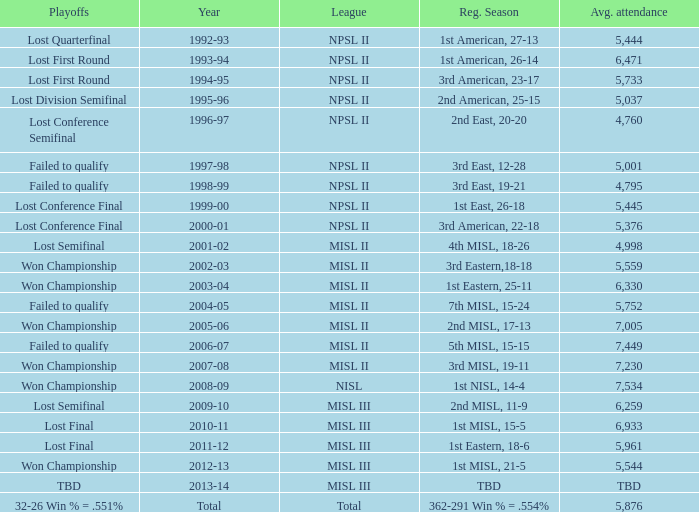Would you mind parsing the complete table? {'header': ['Playoffs', 'Year', 'League', 'Reg. Season', 'Avg. attendance'], 'rows': [['Lost Quarterfinal', '1992-93', 'NPSL II', '1st American, 27-13', '5,444'], ['Lost First Round', '1993-94', 'NPSL II', '1st American, 26-14', '6,471'], ['Lost First Round', '1994-95', 'NPSL II', '3rd American, 23-17', '5,733'], ['Lost Division Semifinal', '1995-96', 'NPSL II', '2nd American, 25-15', '5,037'], ['Lost Conference Semifinal', '1996-97', 'NPSL II', '2nd East, 20-20', '4,760'], ['Failed to qualify', '1997-98', 'NPSL II', '3rd East, 12-28', '5,001'], ['Failed to qualify', '1998-99', 'NPSL II', '3rd East, 19-21', '4,795'], ['Lost Conference Final', '1999-00', 'NPSL II', '1st East, 26-18', '5,445'], ['Lost Conference Final', '2000-01', 'NPSL II', '3rd American, 22-18', '5,376'], ['Lost Semifinal', '2001-02', 'MISL II', '4th MISL, 18-26', '4,998'], ['Won Championship', '2002-03', 'MISL II', '3rd Eastern,18-18', '5,559'], ['Won Championship', '2003-04', 'MISL II', '1st Eastern, 25-11', '6,330'], ['Failed to qualify', '2004-05', 'MISL II', '7th MISL, 15-24', '5,752'], ['Won Championship', '2005-06', 'MISL II', '2nd MISL, 17-13', '7,005'], ['Failed to qualify', '2006-07', 'MISL II', '5th MISL, 15-15', '7,449'], ['Won Championship', '2007-08', 'MISL II', '3rd MISL, 19-11', '7,230'], ['Won Championship', '2008-09', 'NISL', '1st NISL, 14-4', '7,534'], ['Lost Semifinal', '2009-10', 'MISL III', '2nd MISL, 11-9', '6,259'], ['Lost Final', '2010-11', 'MISL III', '1st MISL, 15-5', '6,933'], ['Lost Final', '2011-12', 'MISL III', '1st Eastern, 18-6', '5,961'], ['Won Championship', '2012-13', 'MISL III', '1st MISL, 21-5', '5,544'], ['TBD', '2013-14', 'MISL III', 'TBD', 'TBD'], ['32-26 Win % = .551%', 'Total', 'Total', '362-291 Win % = .554%', '5,876']]} When was the year that had an average attendance of 5,445? 1999-00. 